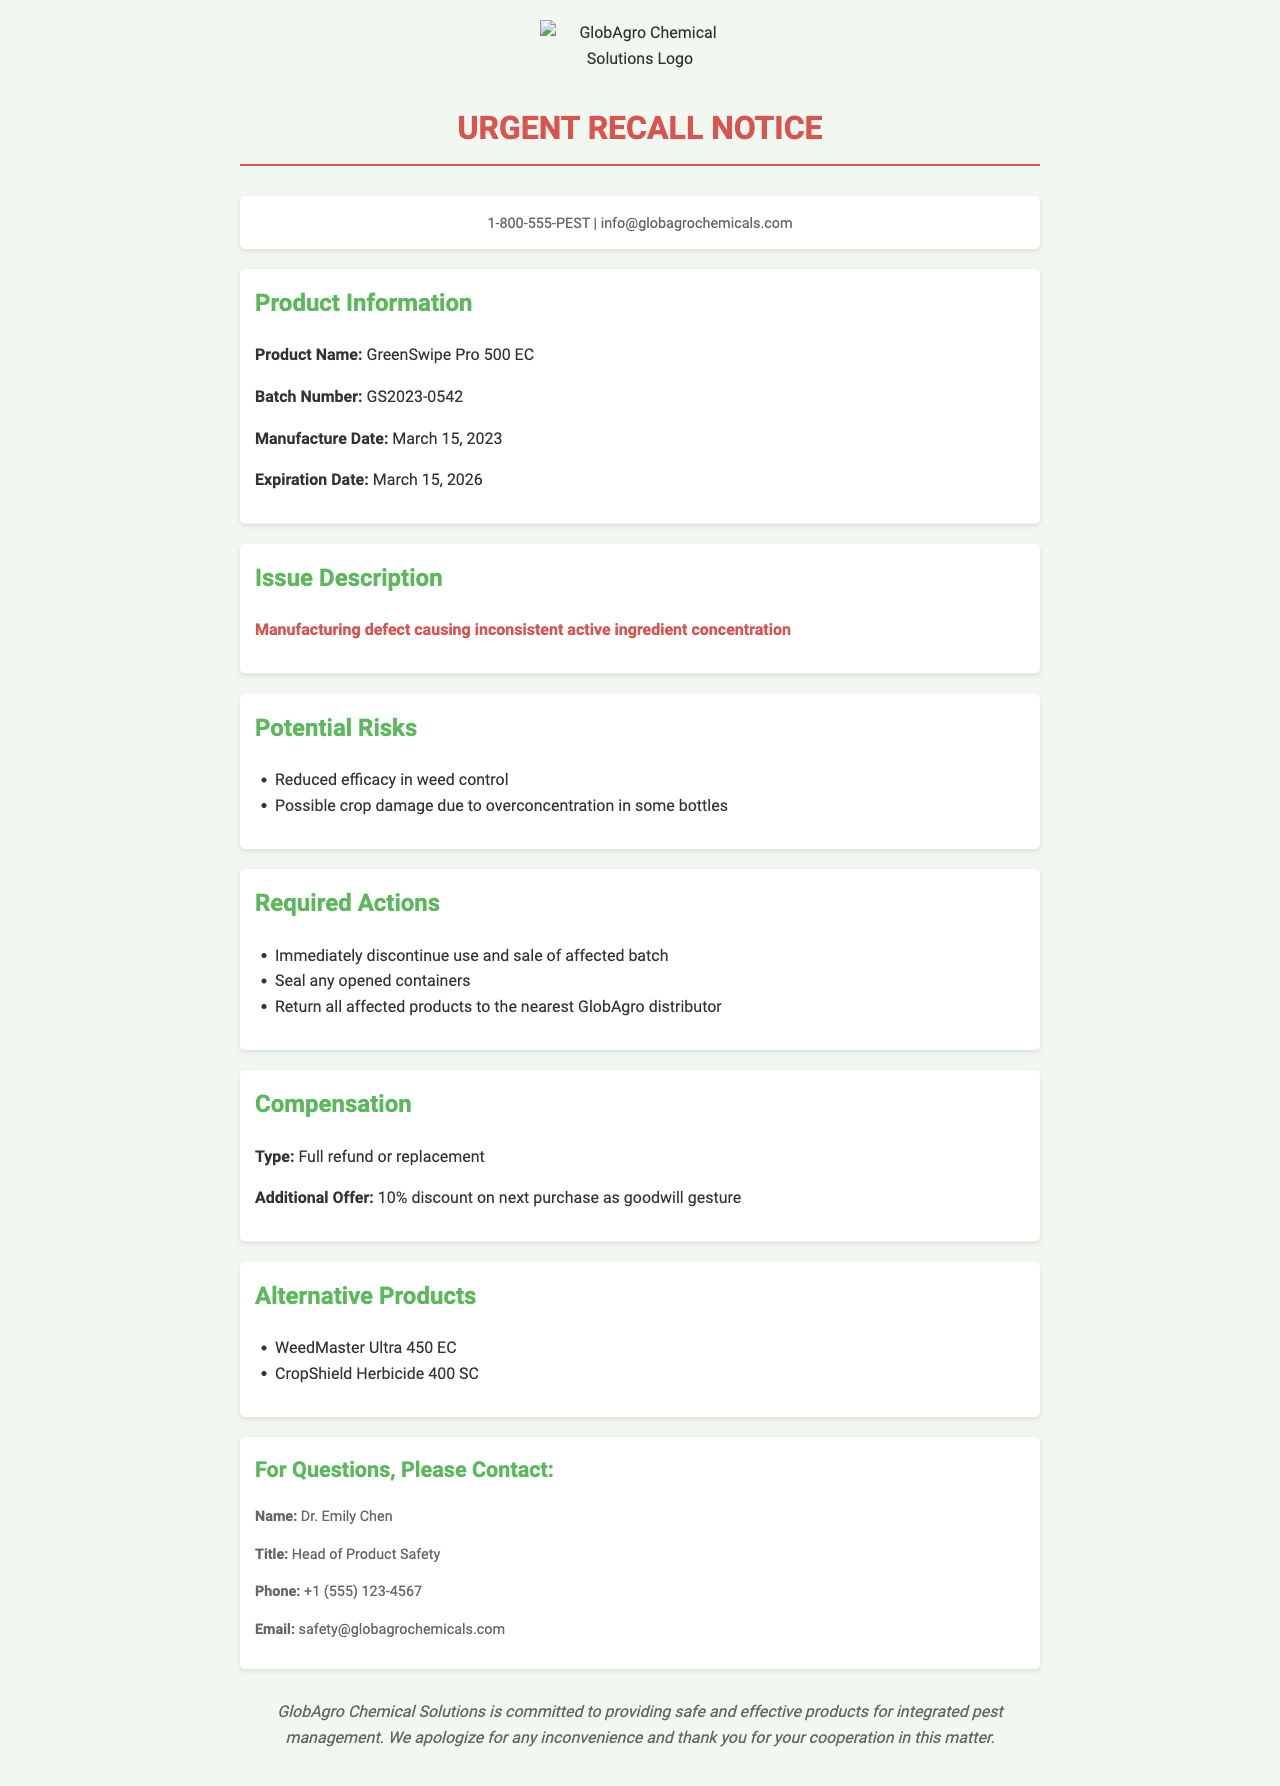What is the product name? The product name is explicitly stated in the document under "Product Information."
Answer: GreenSwipe Pro 500 EC What is the batch number? The batch number is mentioned in the same section as the product name.
Answer: GS2023-0542 What is the manufacture date? The manufacture date is detailed in the "Product Information" section.
Answer: March 15, 2023 What are the potential risks mentioned? The document lists potential risks under "Potential Risks," including two specific entries.
Answer: Reduced efficacy in weed control, Possible crop damage due to overconcentration in some bottles What actions are required regarding the affected batch? Required actions are outlined in the "Required Actions" section of the document.
Answer: Immediately discontinue use and sale of affected batch What type of compensation is offered? The type of compensation can be found in the "Compensation" section, specifying what is being offered.
Answer: Full refund or replacement What contact information is provided for questions? The contact information section includes details about who to contact for further inquiries.
Answer: Dr. Emily Chen, safety@globagrochemicals.com Which alternative products are mentioned? The alternative products are listed in the "Alternative Products" section of the document.
Answer: WeedMaster Ultra 450 EC, CropShield Herbicide 400 SC What was the reason for the recall? The reason for the recall is stated in the "Issue Description" section.
Answer: Manufacturing defect causing inconsistent active ingredient concentration What is the goodwill gesture offered with compensation? The additional offer as a goodwill gesture is included in the "Compensation" section.
Answer: 10% discount on next purchase 